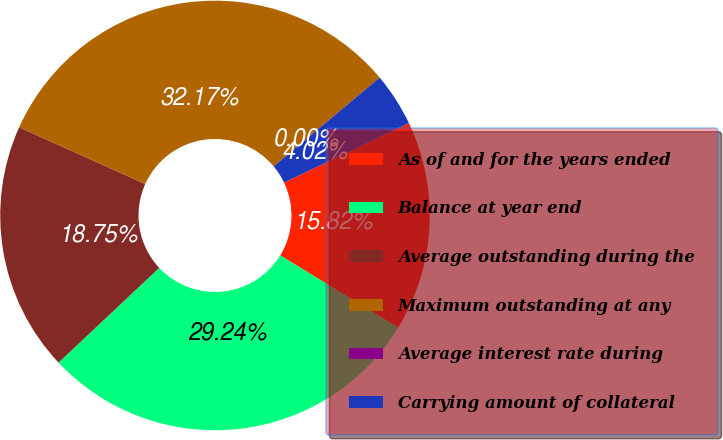Convert chart to OTSL. <chart><loc_0><loc_0><loc_500><loc_500><pie_chart><fcel>As of and for the years ended<fcel>Balance at year end<fcel>Average outstanding during the<fcel>Maximum outstanding at any<fcel>Average interest rate during<fcel>Carrying amount of collateral<nl><fcel>15.82%<fcel>29.24%<fcel>18.75%<fcel>32.17%<fcel>0.0%<fcel>4.02%<nl></chart> 